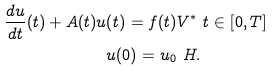<formula> <loc_0><loc_0><loc_500><loc_500>\frac { d u } { d t } ( t ) + A ( t ) u ( t ) = f ( t ) & V ^ { \ast } \ t \in [ 0 , T ] \\ u ( 0 ) = u _ { 0 } & \ H .</formula> 